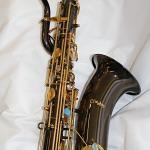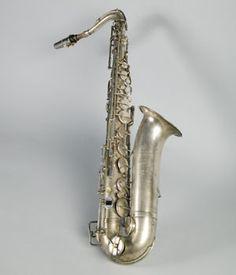The first image is the image on the left, the second image is the image on the right. Analyze the images presented: Is the assertion "An image shows an instrument with a very dark finish and brass works." valid? Answer yes or no. Yes. The first image is the image on the left, the second image is the image on the right. Analyze the images presented: Is the assertion "The reed end of two saxophones angles upward." valid? Answer yes or no. No. 